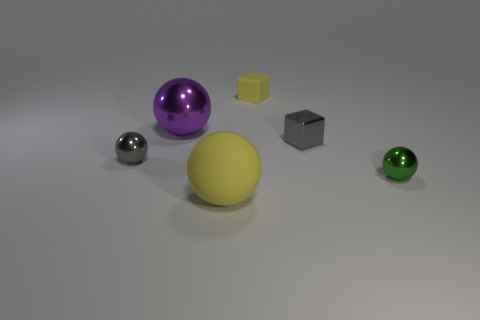What material is the big object that is the same color as the rubber block?
Your answer should be compact. Rubber. What number of other objects are there of the same color as the large matte object?
Your answer should be very brief. 1. How many gray spheres are there?
Offer a very short reply. 1. What material is the yellow object in front of the tiny shiny ball that is left of the tiny metal block?
Make the answer very short. Rubber. There is a gray ball that is the same size as the green shiny thing; what is it made of?
Your answer should be compact. Metal. Do the yellow matte thing in front of the gray shiny sphere and the tiny gray shiny block have the same size?
Provide a succinct answer. No. Do the small metallic object that is to the right of the gray metallic cube and the large yellow rubber object have the same shape?
Make the answer very short. Yes. What number of things are either big yellow objects or shiny things in front of the small gray ball?
Provide a short and direct response. 2. Is the number of big purple shiny things less than the number of small spheres?
Ensure brevity in your answer.  Yes. Is the number of green shiny objects greater than the number of small cyan matte cylinders?
Offer a terse response. Yes. 